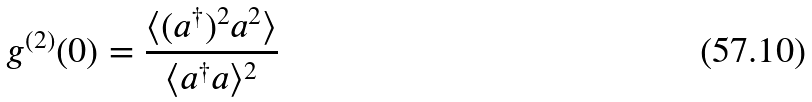<formula> <loc_0><loc_0><loc_500><loc_500>g ^ { ( 2 ) } ( 0 ) = \frac { \langle ( a ^ { \dagger } ) ^ { 2 } a ^ { 2 } \rangle } { \langle a ^ { \dagger } a \rangle ^ { 2 } }</formula> 